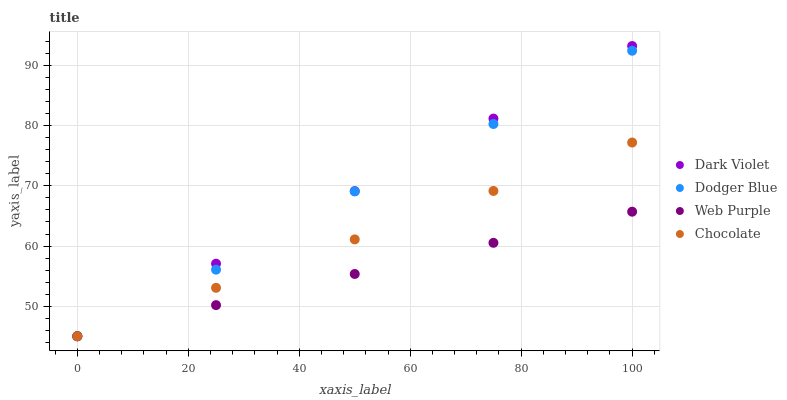Does Web Purple have the minimum area under the curve?
Answer yes or no. Yes. Does Dark Violet have the maximum area under the curve?
Answer yes or no. Yes. Does Dodger Blue have the minimum area under the curve?
Answer yes or no. No. Does Dodger Blue have the maximum area under the curve?
Answer yes or no. No. Is Dark Violet the smoothest?
Answer yes or no. Yes. Is Dodger Blue the roughest?
Answer yes or no. Yes. Is Dodger Blue the smoothest?
Answer yes or no. No. Is Dark Violet the roughest?
Answer yes or no. No. Does Web Purple have the lowest value?
Answer yes or no. Yes. Does Dark Violet have the highest value?
Answer yes or no. Yes. Does Dodger Blue have the highest value?
Answer yes or no. No. Does Chocolate intersect Web Purple?
Answer yes or no. Yes. Is Chocolate less than Web Purple?
Answer yes or no. No. Is Chocolate greater than Web Purple?
Answer yes or no. No. 